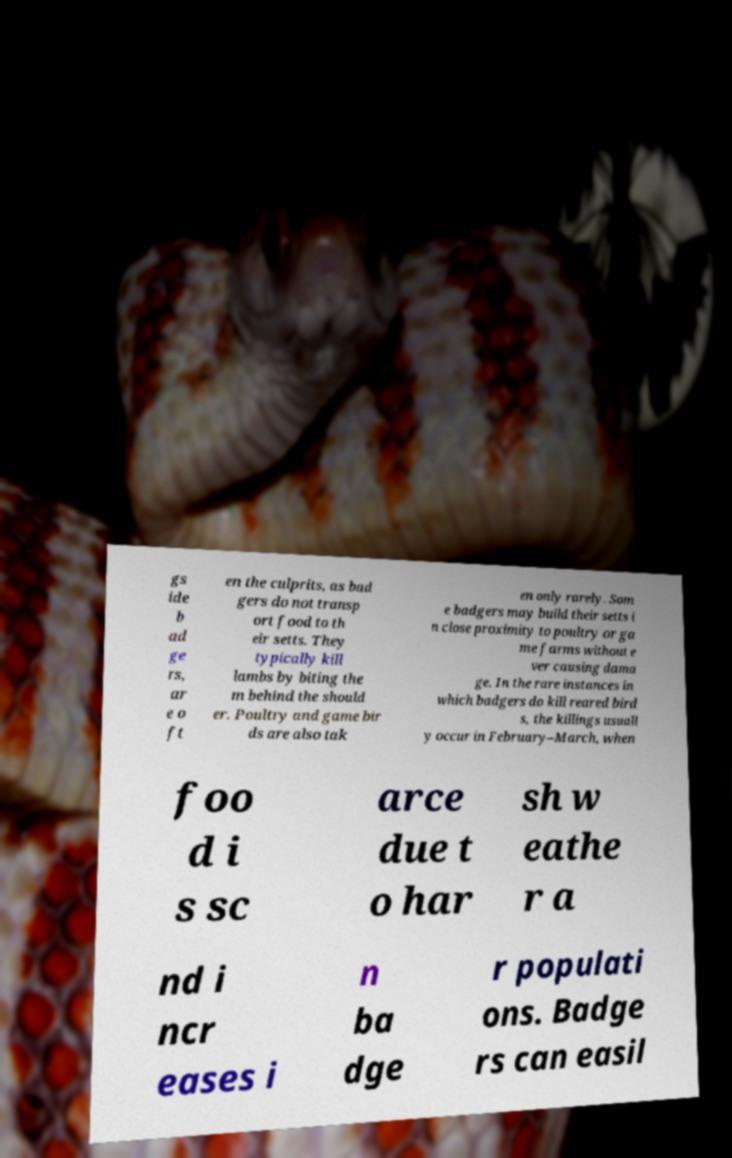Can you accurately transcribe the text from the provided image for me? gs ide b ad ge rs, ar e o ft en the culprits, as bad gers do not transp ort food to th eir setts. They typically kill lambs by biting the m behind the should er. Poultry and game bir ds are also tak en only rarely. Som e badgers may build their setts i n close proximity to poultry or ga me farms without e ver causing dama ge. In the rare instances in which badgers do kill reared bird s, the killings usuall y occur in February–March, when foo d i s sc arce due t o har sh w eathe r a nd i ncr eases i n ba dge r populati ons. Badge rs can easil 